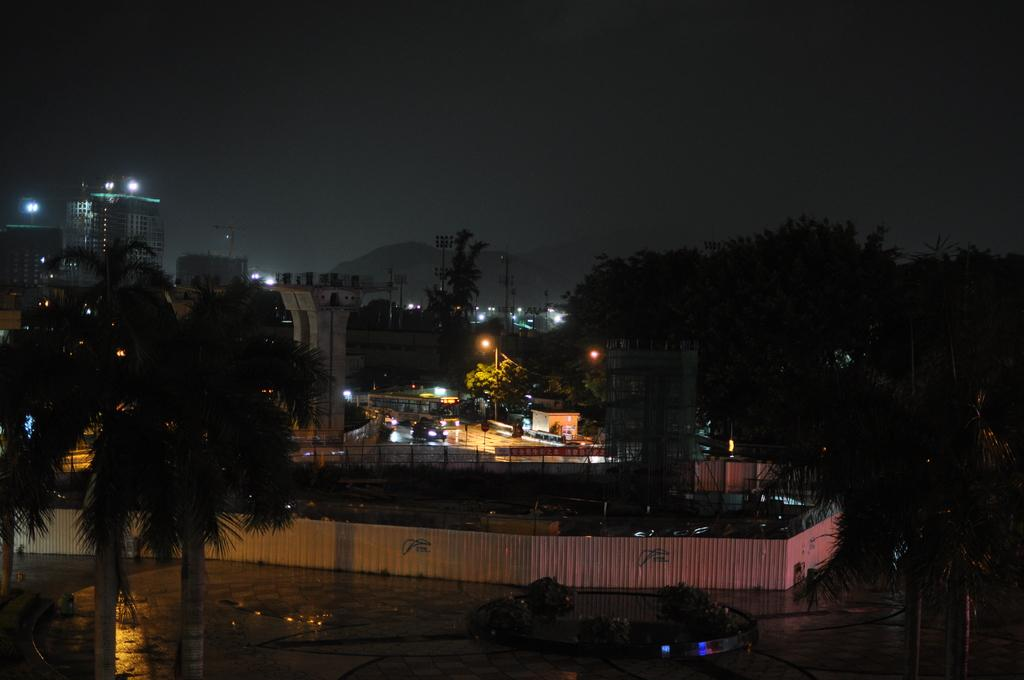What type of structures can be seen in the image? There are buildings in the image. What natural elements are present in the image? There are trees in the image. What type of fencing is around the ground in the image? There is iron sheet fencing around the ground. What is the condition of the sky in the image? The sky is clear in the image. How would you describe the lighting in the image? The image is dark. Can you see a scarecrow's face in the image? There is no scarecrow present in the image. Is there a crook visible in the image? There is no crook present in the image. 